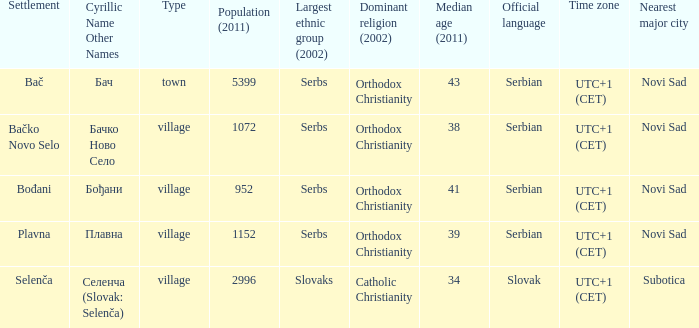What is the ethnic majority in the only town? Serbs. 